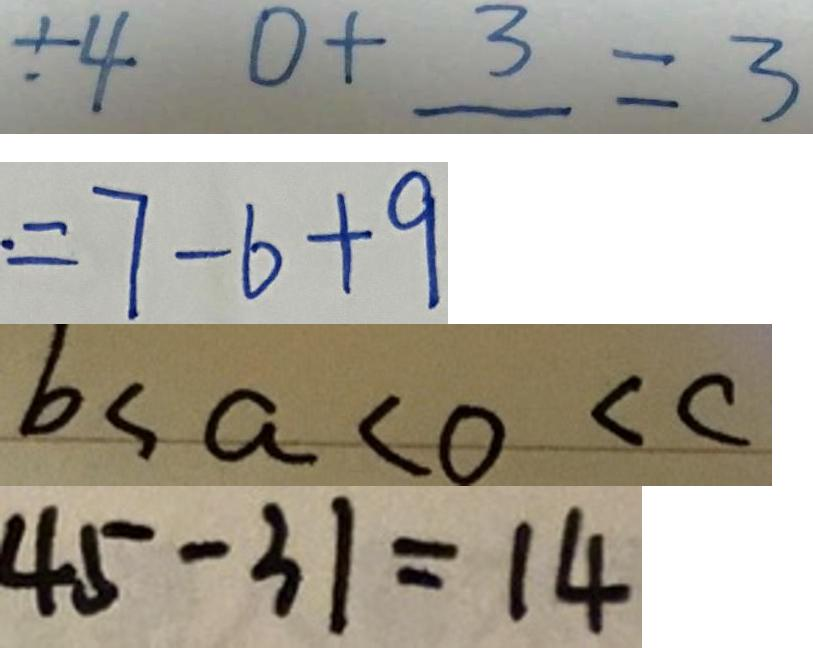Convert formula to latex. <formula><loc_0><loc_0><loc_500><loc_500>\div 4 0 + 3 = 3 
 = 7 - 6 + 9 
 b < a < 0 < c 
 4 5 - 3 1 = 1 4</formula> 